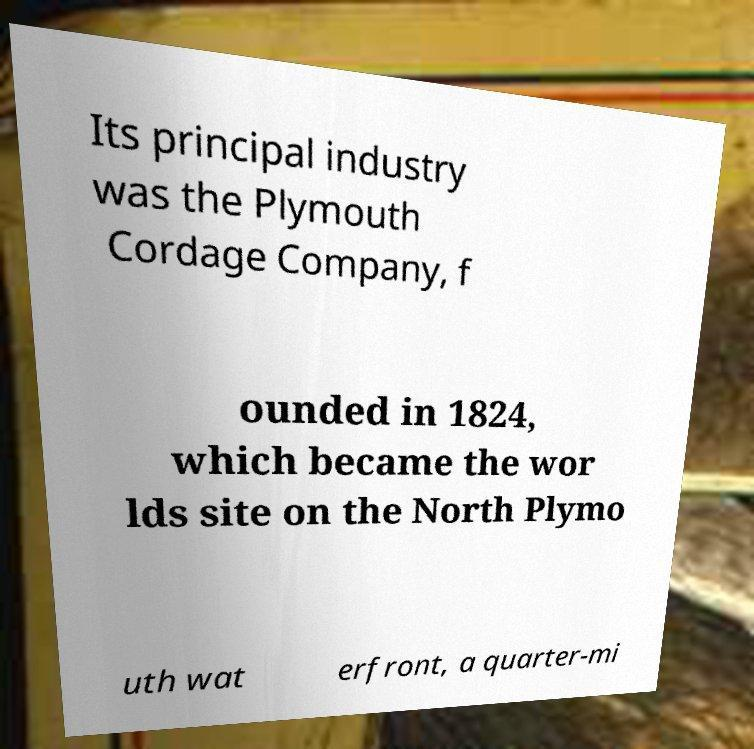Can you read and provide the text displayed in the image?This photo seems to have some interesting text. Can you extract and type it out for me? Its principal industry was the Plymouth Cordage Company, f ounded in 1824, which became the wor lds site on the North Plymo uth wat erfront, a quarter-mi 